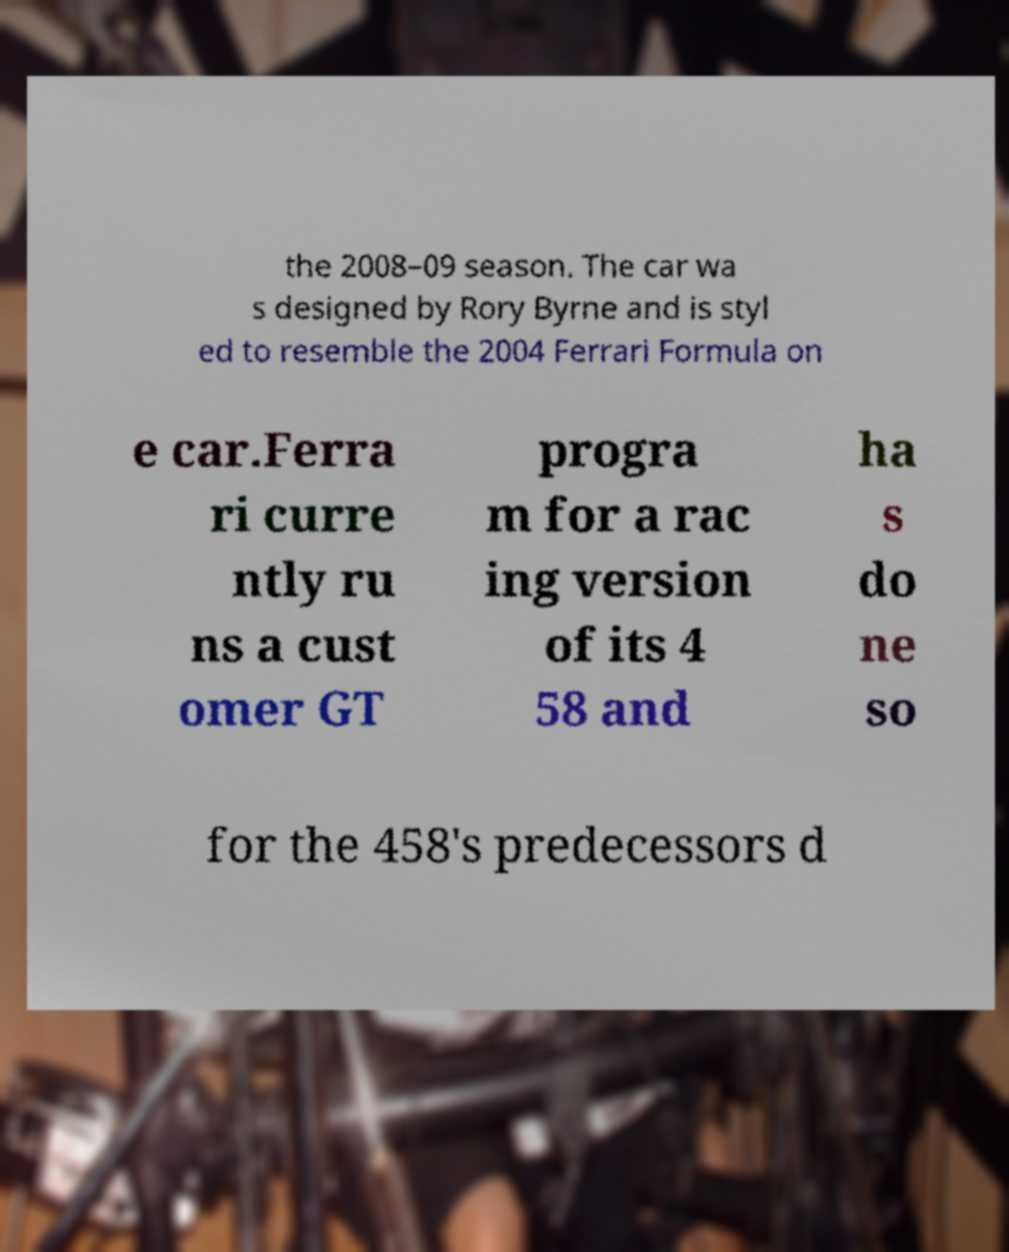Could you assist in decoding the text presented in this image and type it out clearly? the 2008–09 season. The car wa s designed by Rory Byrne and is styl ed to resemble the 2004 Ferrari Formula on e car.Ferra ri curre ntly ru ns a cust omer GT progra m for a rac ing version of its 4 58 and ha s do ne so for the 458's predecessors d 